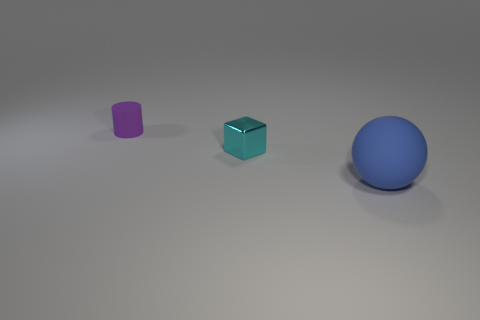What color is the tiny thing that is in front of the matte thing that is behind the big blue ball?
Provide a short and direct response. Cyan. Is the purple rubber object the same size as the metallic thing?
Provide a succinct answer. Yes. What number of blue spheres have the same size as the cyan metallic cube?
Ensure brevity in your answer.  0. What is the color of the small thing that is made of the same material as the big blue object?
Your answer should be compact. Purple. Are there fewer small purple metal blocks than blue matte spheres?
Provide a short and direct response. Yes. How many purple objects are balls or large cylinders?
Give a very brief answer. 0. What number of rubber objects are both to the left of the cyan cube and in front of the cube?
Provide a short and direct response. 0. Is the material of the block the same as the big ball?
Your answer should be very brief. No. There is a purple object that is the same size as the cyan thing; what shape is it?
Ensure brevity in your answer.  Cylinder. Are there more blue rubber cylinders than blue objects?
Provide a short and direct response. No. 